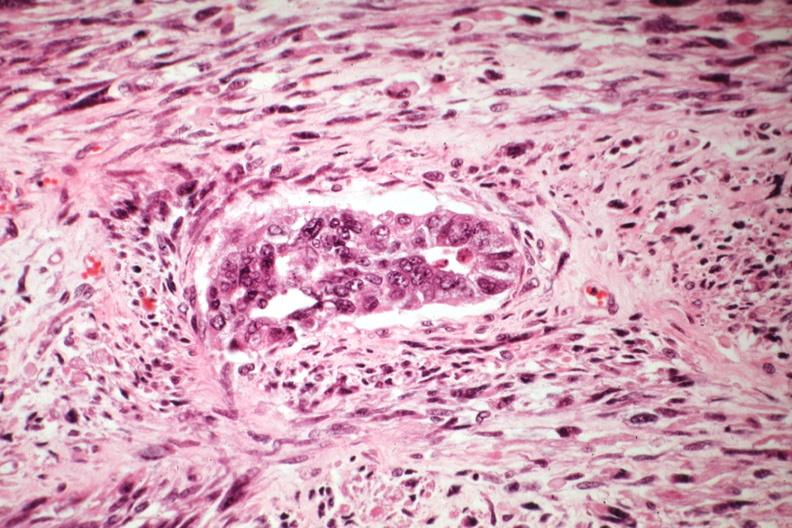s very good example present?
Answer the question using a single word or phrase. No 